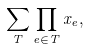Convert formula to latex. <formula><loc_0><loc_0><loc_500><loc_500>\sum _ { T } \prod _ { e \in T } x _ { e } ,</formula> 